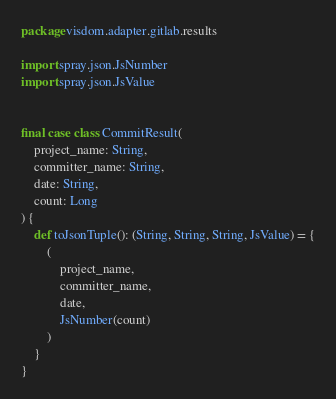Convert code to text. <code><loc_0><loc_0><loc_500><loc_500><_Scala_>package visdom.adapter.gitlab.results

import spray.json.JsNumber
import spray.json.JsValue


final case class CommitResult(
    project_name: String,
    committer_name: String,
    date: String,
    count: Long
) {
    def toJsonTuple(): (String, String, String, JsValue) = {
        (
            project_name,
            committer_name,
            date,
            JsNumber(count)
        )
    }
}
</code> 